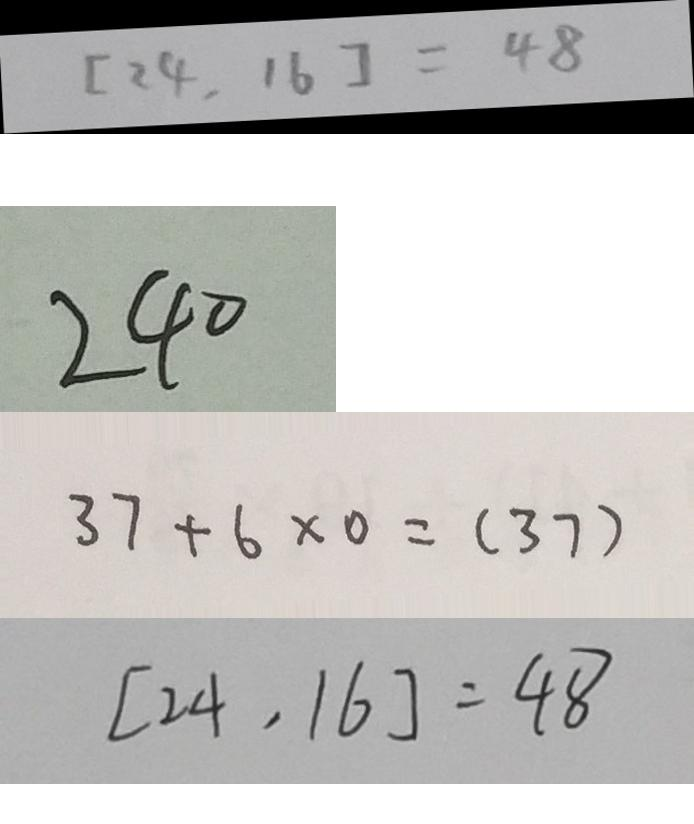Convert formula to latex. <formula><loc_0><loc_0><loc_500><loc_500>[ 2 4 , 1 6 ] = 4 8 
 2 4 0 
 3 7 + 6 \times 0 = ( 3 7 ) 
 [ 2 4 , 1 6 ] = 4 8</formula> 